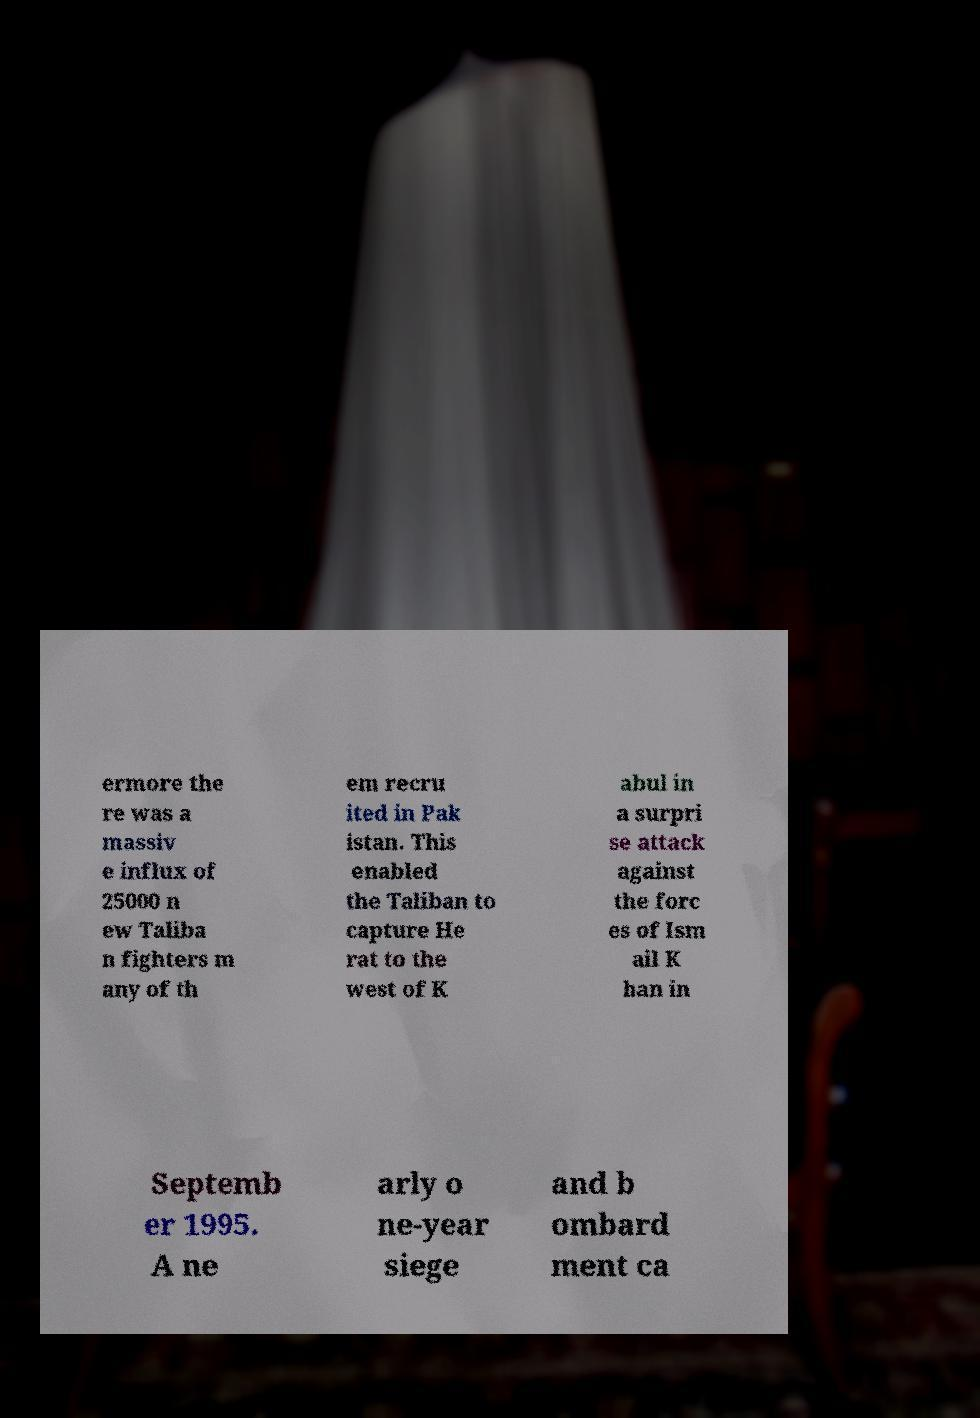There's text embedded in this image that I need extracted. Can you transcribe it verbatim? ermore the re was a massiv e influx of 25000 n ew Taliba n fighters m any of th em recru ited in Pak istan. This enabled the Taliban to capture He rat to the west of K abul in a surpri se attack against the forc es of Ism ail K han in Septemb er 1995. A ne arly o ne-year siege and b ombard ment ca 